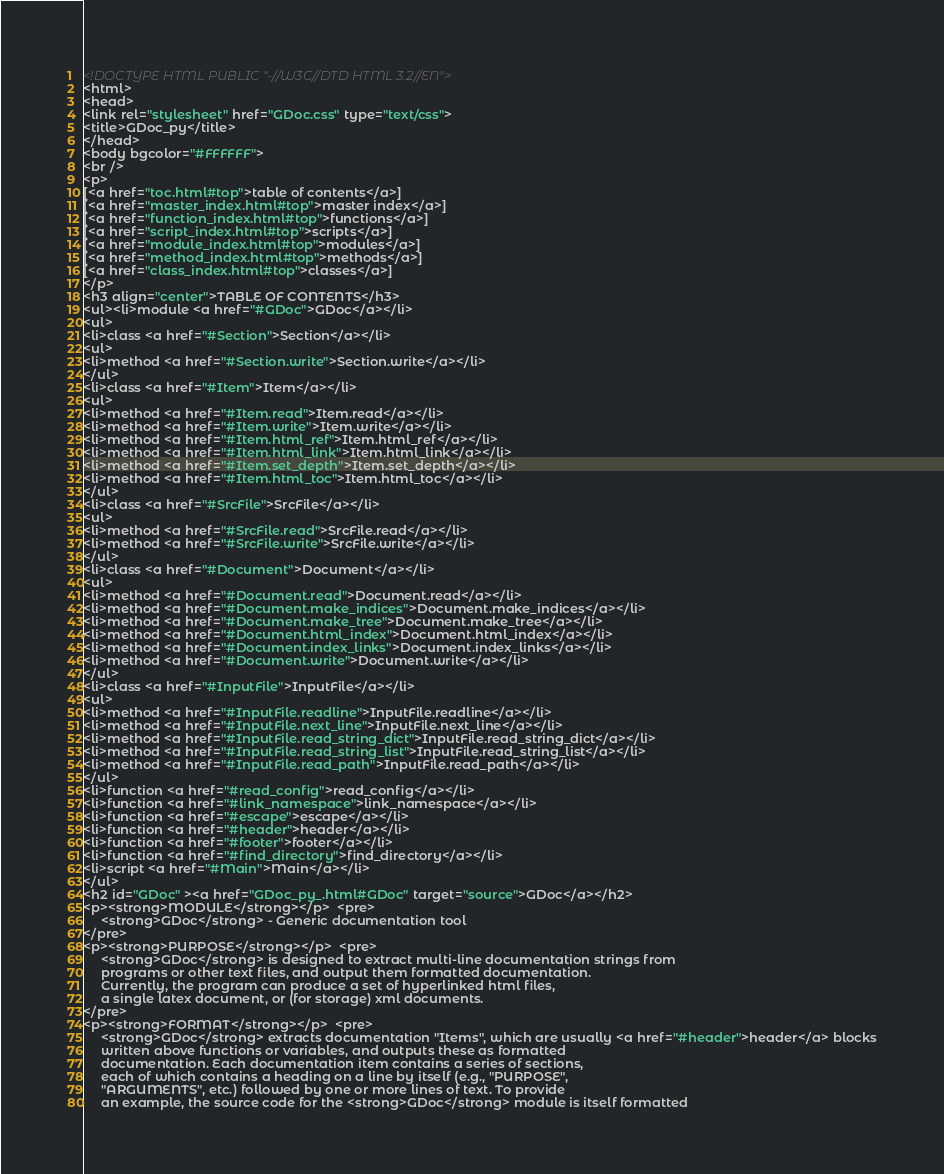<code> <loc_0><loc_0><loc_500><loc_500><_HTML_><!DOCTYPE HTML PUBLIC "-//W3C//DTD HTML 3.2//EN">
<html>
<head>
<link rel="stylesheet" href="GDoc.css" type="text/css">
<title>GDoc_py</title>
</head>
<body bgcolor="#FFFFFF">
<br />
<p>
[<a href="toc.html#top">table of contents</a>]
[<a href="master_index.html#top">master index</a>]
[<a href="function_index.html#top">functions</a>]
[<a href="script_index.html#top">scripts</a>]
[<a href="module_index.html#top">modules</a>]
[<a href="method_index.html#top">methods</a>]
[<a href="class_index.html#top">classes</a>]
</p>
<h3 align="center">TABLE OF CONTENTS</h3>
<ul><li>module <a href="#GDoc">GDoc</a></li>
<ul>
<li>class <a href="#Section">Section</a></li>
<ul>
<li>method <a href="#Section.write">Section.write</a></li>
</ul>
<li>class <a href="#Item">Item</a></li>
<ul>
<li>method <a href="#Item.read">Item.read</a></li>
<li>method <a href="#Item.write">Item.write</a></li>
<li>method <a href="#Item.html_ref">Item.html_ref</a></li>
<li>method <a href="#Item.html_link">Item.html_link</a></li>
<li>method <a href="#Item.set_depth">Item.set_depth</a></li>
<li>method <a href="#Item.html_toc">Item.html_toc</a></li>
</ul>
<li>class <a href="#SrcFile">SrcFile</a></li>
<ul>
<li>method <a href="#SrcFile.read">SrcFile.read</a></li>
<li>method <a href="#SrcFile.write">SrcFile.write</a></li>
</ul>
<li>class <a href="#Document">Document</a></li>
<ul>
<li>method <a href="#Document.read">Document.read</a></li>
<li>method <a href="#Document.make_indices">Document.make_indices</a></li>
<li>method <a href="#Document.make_tree">Document.make_tree</a></li>
<li>method <a href="#Document.html_index">Document.html_index</a></li>
<li>method <a href="#Document.index_links">Document.index_links</a></li>
<li>method <a href="#Document.write">Document.write</a></li>
</ul>
<li>class <a href="#InputFile">InputFile</a></li>
<ul>
<li>method <a href="#InputFile.readline">InputFile.readline</a></li>
<li>method <a href="#InputFile.next_line">InputFile.next_line</a></li>
<li>method <a href="#InputFile.read_string_dict">InputFile.read_string_dict</a></li>
<li>method <a href="#InputFile.read_string_list">InputFile.read_string_list</a></li>
<li>method <a href="#InputFile.read_path">InputFile.read_path</a></li>
</ul>
<li>function <a href="#read_config">read_config</a></li>
<li>function <a href="#link_namespace">link_namespace</a></li>
<li>function <a href="#escape">escape</a></li>
<li>function <a href="#header">header</a></li>
<li>function <a href="#footer">footer</a></li>
<li>function <a href="#find_directory">find_directory</a></li>
<li>script <a href="#Main">Main</a></li>
</ul>
<h2 id="GDoc" ><a href="GDoc_py_.html#GDoc" target="source">GDoc</a></h2>
<p><strong>MODULE</strong></p>  <pre>
     <strong>GDoc</strong> - Generic documentation tool
</pre>
<p><strong>PURPOSE</strong></p>  <pre>
     <strong>GDoc</strong> is designed to extract multi-line documentation strings from
     programs or other text files, and output them formatted documentation.
     Currently, the program can produce a set of hyperlinked html files, 
     a single latex document, or (for storage) xml documents.
</pre>
<p><strong>FORMAT</strong></p>  <pre>
     <strong>GDoc</strong> extracts documentation "Items", which are usually <a href="#header">header</a> blocks
     written above functions or variables, and outputs these as formatted 
     documentation. Each documentation item contains a series of sections,
     each of which contains a heading on a line by itself (e.g., "PURPOSE",
     "ARGUMENTS", etc.) followed by one or more lines of text. To provide
     an example, the source code for the <strong>GDoc</strong> module is itself formatted </code> 